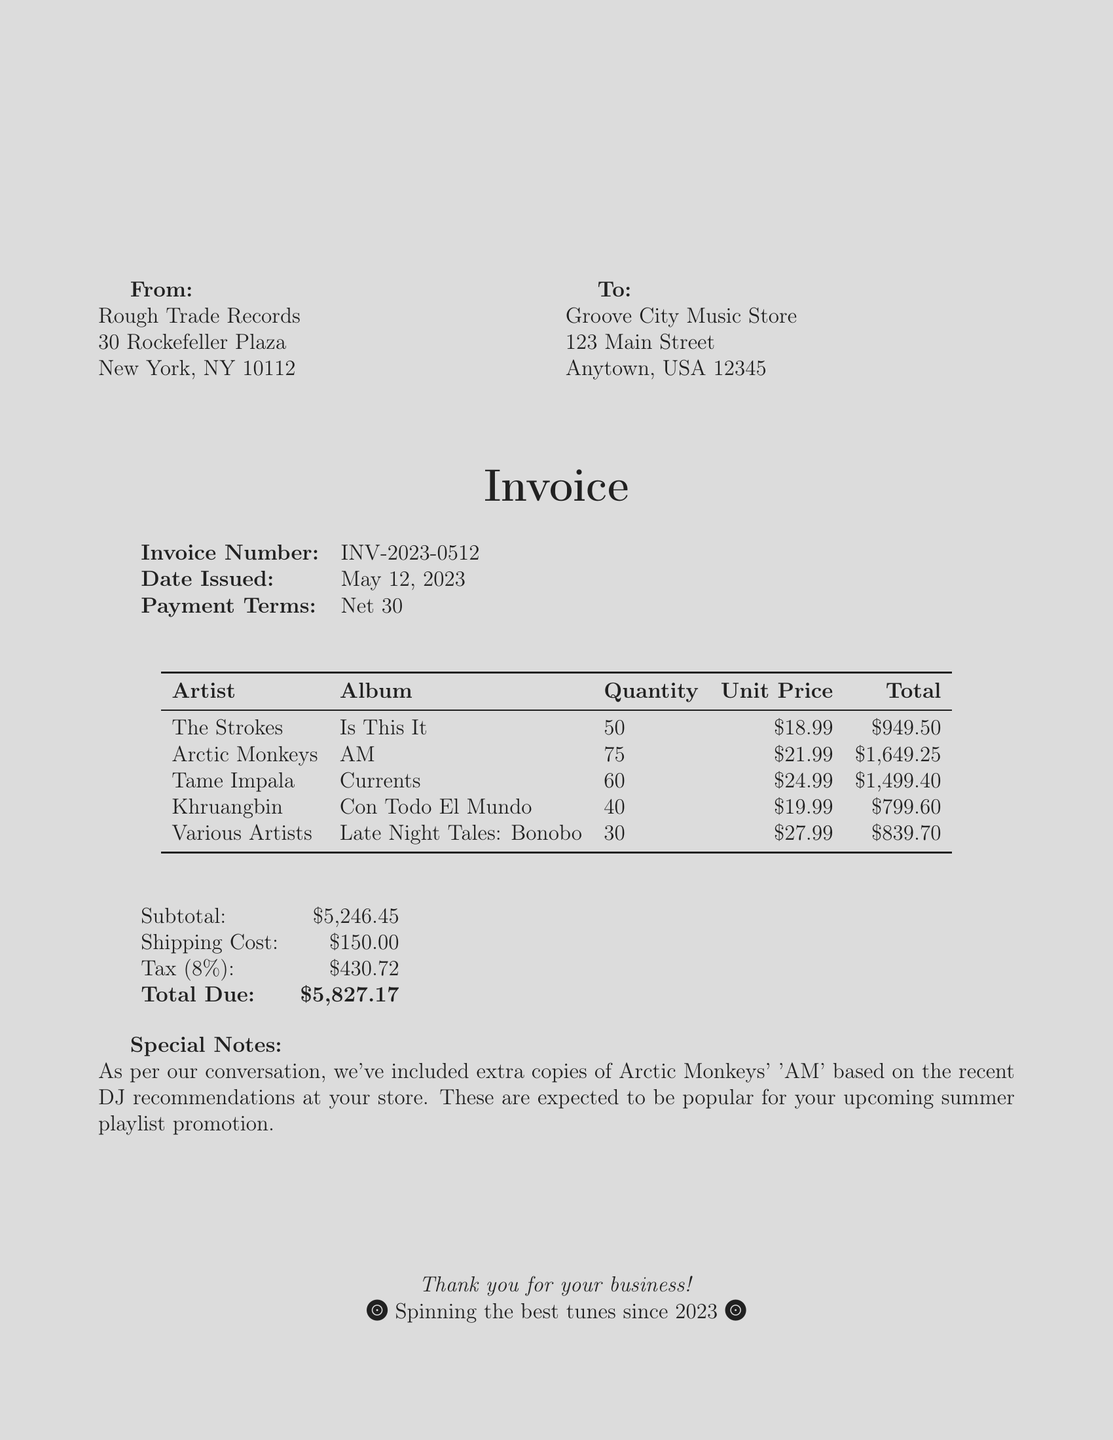What is the invoice number? The invoice number is a unique identifier given to the invoice, shown prominently at the top of the document.
Answer: INV-2023-0512 Who is the supplier? The supplier's name is listed in the "From" section of the document.
Answer: Rough Trade Records What is the total due amount? The total due is calculated from the subtotal, shipping, and tax listed at the end of the invoice.
Answer: $5,827.17 How many copies of 'AM' by Arctic Monkeys were ordered? The quantity ordered is specified in the order details section for each album.
Answer: 75 What is the tax rate applied? The tax rate is explicitly mentioned as a percentage in the financial summary of the invoice.
Answer: 8% What is the shipping cost? The shipping cost is provided as a separate line item in the financial summary.
Answer: $150.00 What special notes are included in the invoice? The special notes section provides additional details about the order based on past conversations.
Answer: Extra copies of Arctic Monkeys' 'AM' were included What date was the invoice issued? The date issued is noted under the invoice details section within the document.
Answer: May 12, 2023 Who is the customer? The customer's name is found in the "To" section at the top of the document.
Answer: Groove City Music Store 